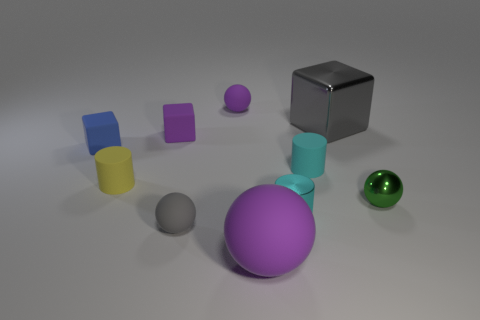Subtract all cubes. How many objects are left? 7 Add 1 cyan cylinders. How many cyan cylinders are left? 3 Add 4 big green spheres. How many big green spheres exist? 4 Subtract 1 gray balls. How many objects are left? 9 Subtract all green metallic things. Subtract all large blue things. How many objects are left? 9 